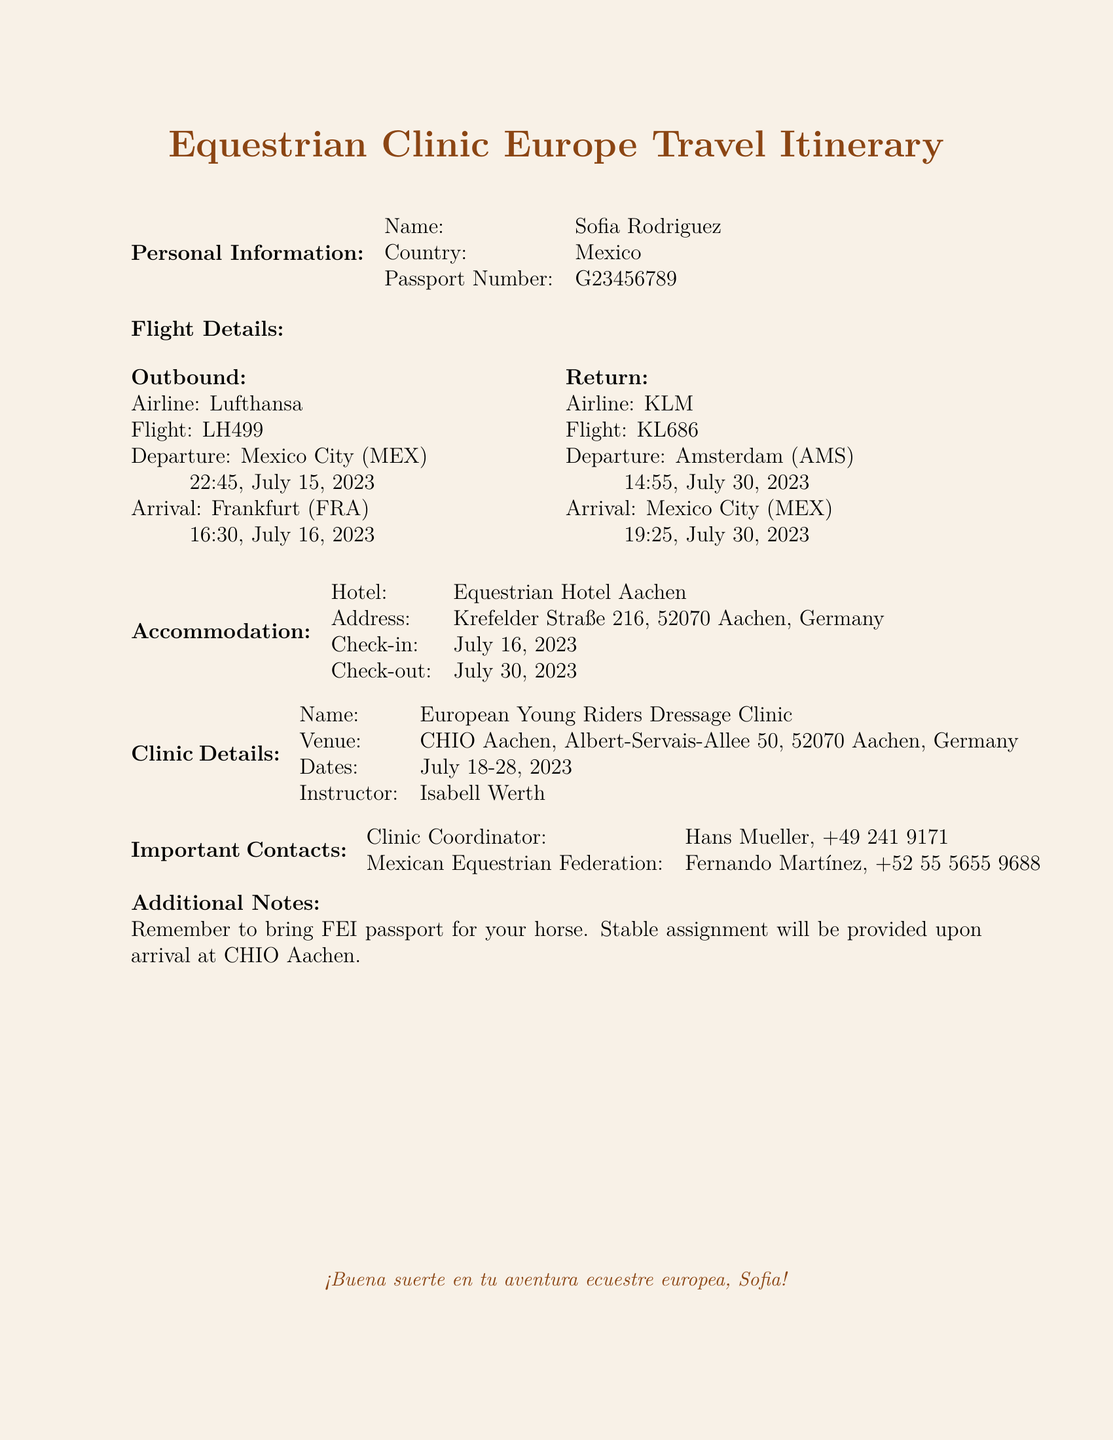What is the name of the clinic? The name of the clinic is listed under "Clinic Details" in the document.
Answer: European Young Riders Dressage Clinic Who is the instructor for the clinic? The instructor's name is provided in the "Clinic Details" section.
Answer: Isabell Werth When is the check-out date from the hotel? The check-out date is found in the "Accommodation" section of the document.
Answer: July 30, 2023 What airline is used for the outbound flight? The airline for the outbound flight is specified in the "Flight Details" section.
Answer: Lufthansa What is the departure time from Mexico City on July 15, 2023? The departure time is listed in the "Flight Details" for the outbound flight.
Answer: 22:45 Where is the accommodation located? The address of the hotel is located in the "Accommodation" section.
Answer: Krefelder Straße 216, 52070 Aachen, Germany Who is the clinic coordinator? The name of the clinic coordinator is specified in the "Important Contacts" section.
Answer: Hans Mueller What should be brought for the horse? The additional notes mention important items related to the horse.
Answer: FEI passport What is the return flight number? The flight number for the return flight is detailed in the "Flight Details" section.
Answer: KL686 